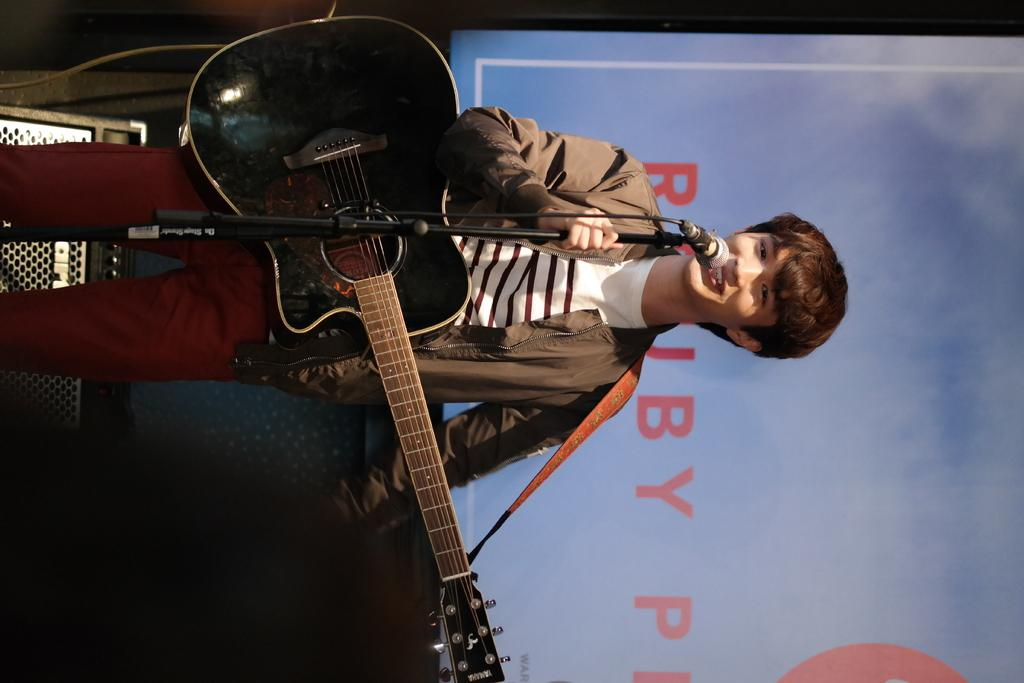What is the person in the image holding? The person is holding a guitar and a microphone. What might the person be doing in the image? The person might be performing or singing, given that they are holding a guitar and a microphone. What can be seen in the background of the image? There is a screen in the background of the image. What is visible on the screen? There is text visible on the screen. What type of underwear is the person wearing in the image? There is no information about the person's underwear in the image, so it cannot be determined. What kind of loaf is being prepared on the screen in the image? There is no loaf or any reference to food preparation in the image; it features a person holding a guitar and a microphone with a screen in the background displaying text. 